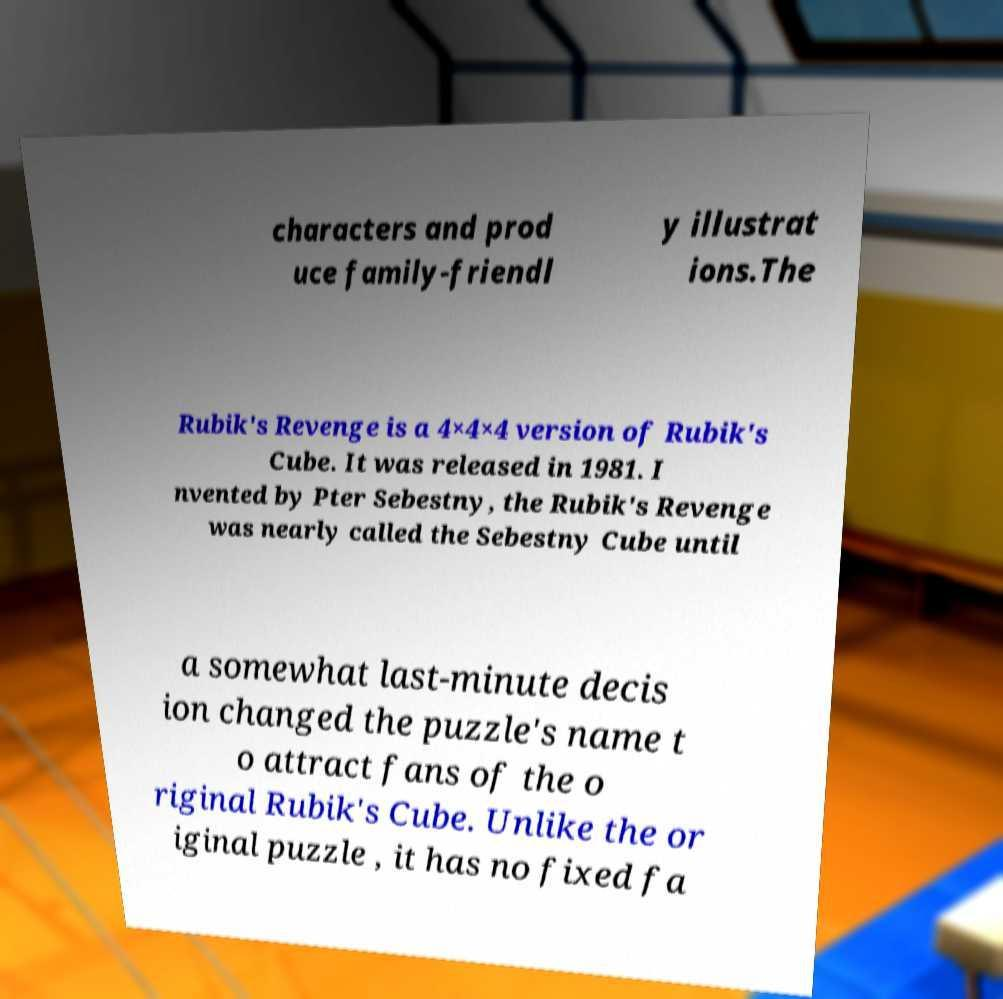Can you read and provide the text displayed in the image?This photo seems to have some interesting text. Can you extract and type it out for me? characters and prod uce family-friendl y illustrat ions.The Rubik's Revenge is a 4×4×4 version of Rubik's Cube. It was released in 1981. I nvented by Pter Sebestny, the Rubik's Revenge was nearly called the Sebestny Cube until a somewhat last-minute decis ion changed the puzzle's name t o attract fans of the o riginal Rubik's Cube. Unlike the or iginal puzzle , it has no fixed fa 